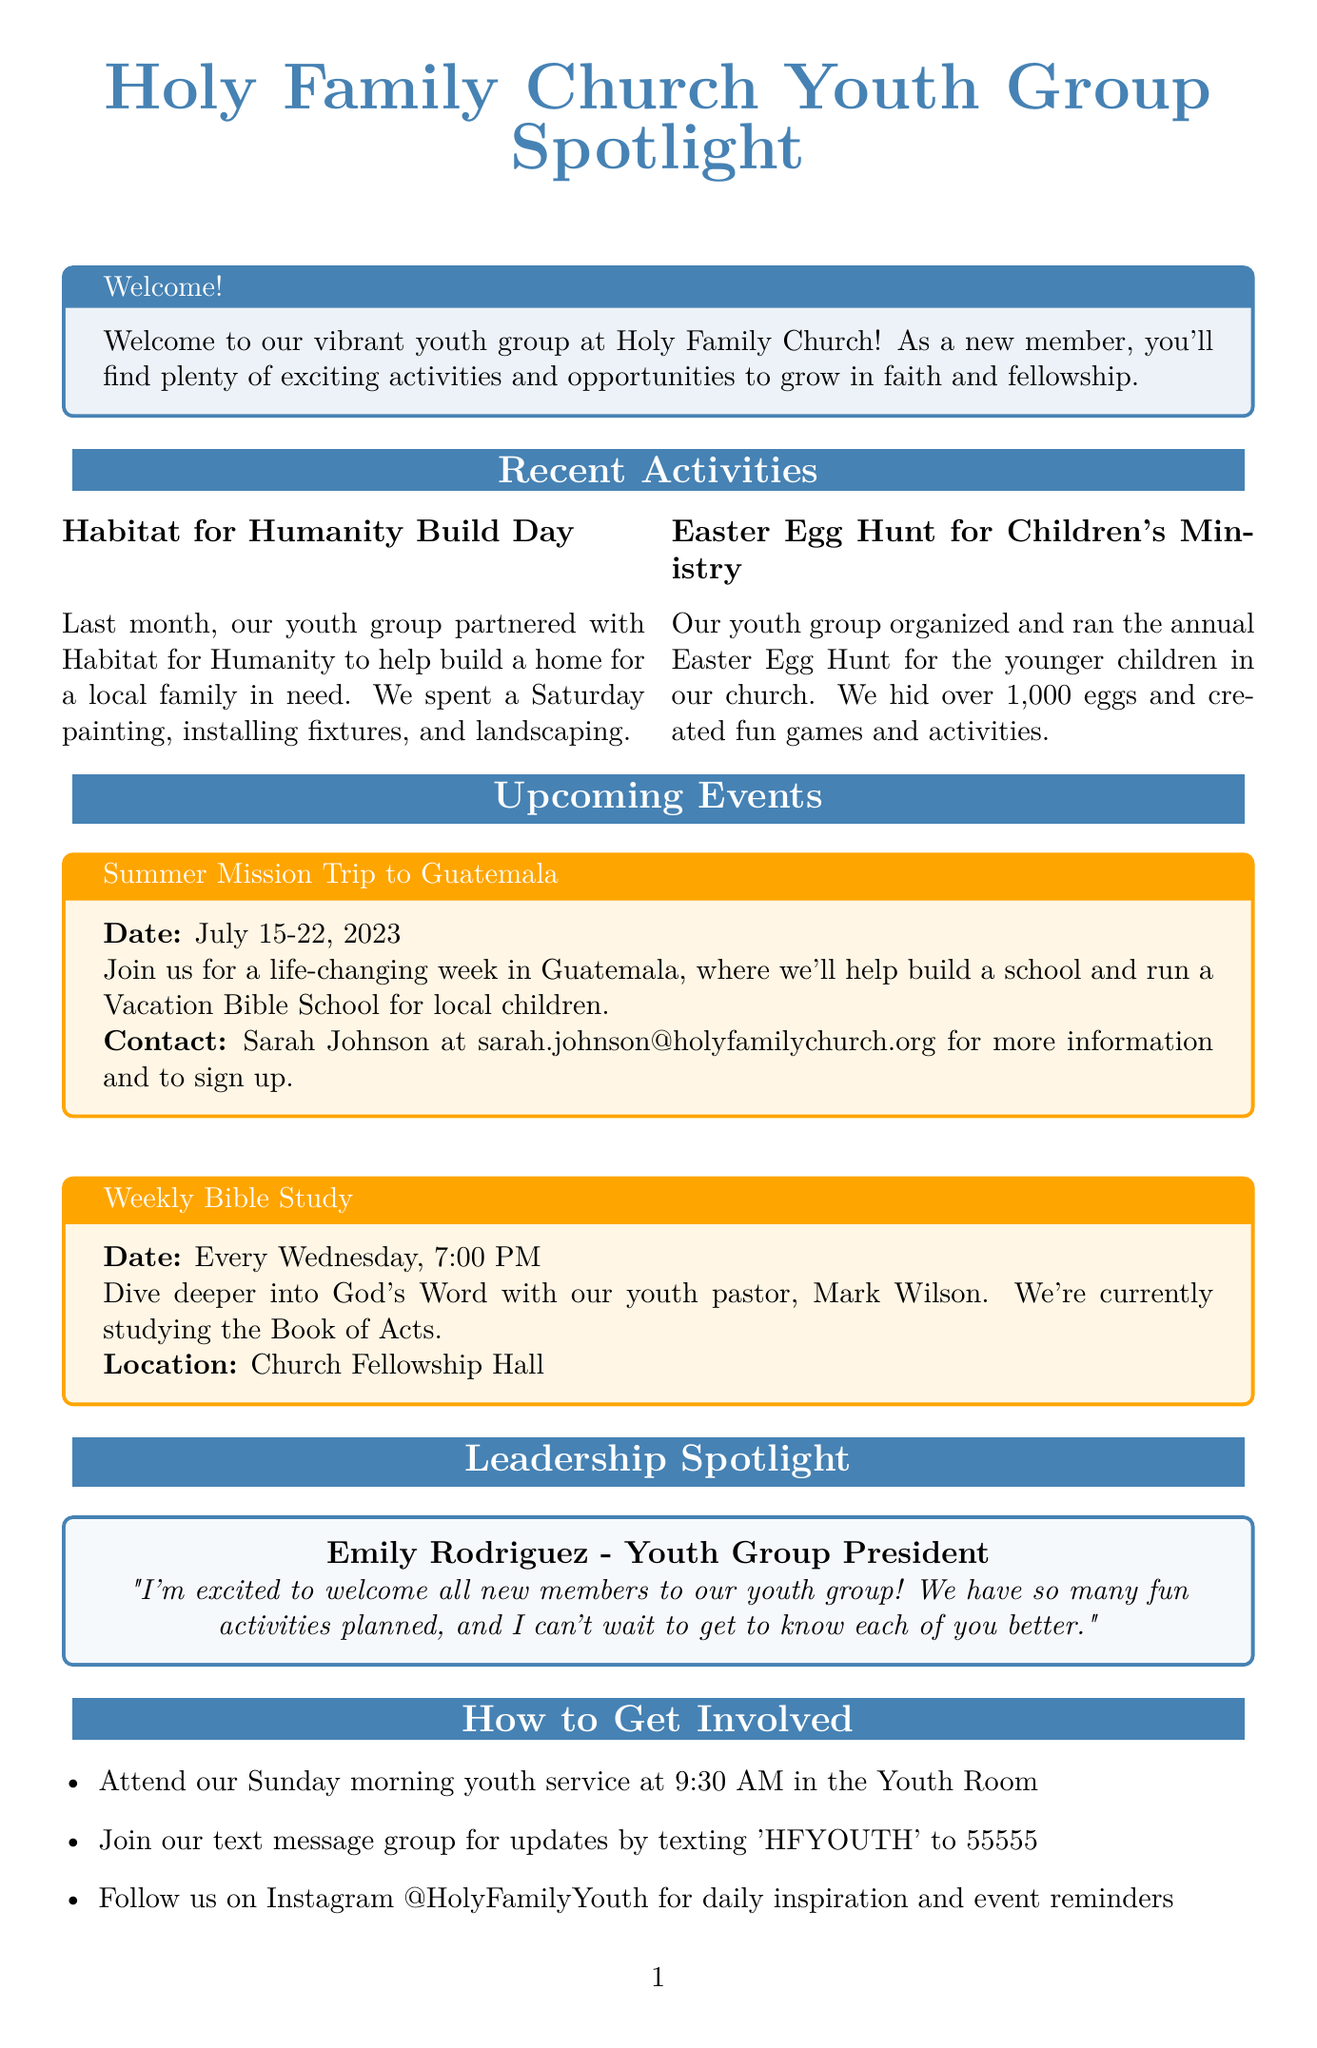What is the title of the newsletter? The title of the newsletter is stated at the beginning of the document.
Answer: Holy Family Church Youth Group Spotlight Who is the Youth Group President? The document provides the name of the individual who holds the position of Youth Group President.
Answer: Emily Rodriguez What activity did the youth group participate in last month? The document mentions a specific initiative the youth group was involved in during the previous month.
Answer: Habitat for Humanity Build Day When is the Summer Mission Trip to Guatemala? The document specifies the dates for the upcoming mission trip event.
Answer: July 15-22, 2023 Where does the Weekly Bible Study take place? The location for the weekly study is detailed in the upcoming events section.
Answer: Church Fellowship Hall What must you do to join the text message group? The document outlines a specific action for joining the communication group.
Answer: Text 'HFYOUTH' to 55555 What is the focus of the current Bible study? The document describes which biblical book the youth group is studying at the moment.
Answer: The Book of Acts What is Emily Rodriguez excited about? The quote in the leadership spotlight conveys what Emily is looking forward to.
Answer: Welcoming all new members What time is the Sunday morning youth service? The document indicates the time for this particular service.
Answer: 9:30 AM 